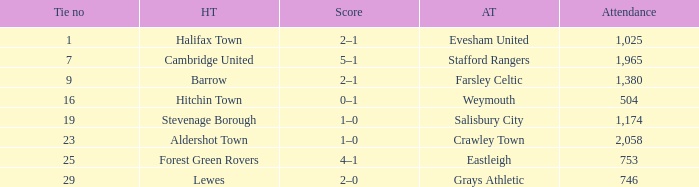Can you give me this table as a dict? {'header': ['Tie no', 'HT', 'Score', 'AT', 'Attendance'], 'rows': [['1', 'Halifax Town', '2–1', 'Evesham United', '1,025'], ['7', 'Cambridge United', '5–1', 'Stafford Rangers', '1,965'], ['9', 'Barrow', '2–1', 'Farsley Celtic', '1,380'], ['16', 'Hitchin Town', '0–1', 'Weymouth', '504'], ['19', 'Stevenage Borough', '1–0', 'Salisbury City', '1,174'], ['23', 'Aldershot Town', '1–0', 'Crawley Town', '2,058'], ['25', 'Forest Green Rovers', '4–1', 'Eastleigh', '753'], ['29', 'Lewes', '2–0', 'Grays Athletic', '746']]} What is the highest attendance for games with stevenage borough at home? 1174.0. 